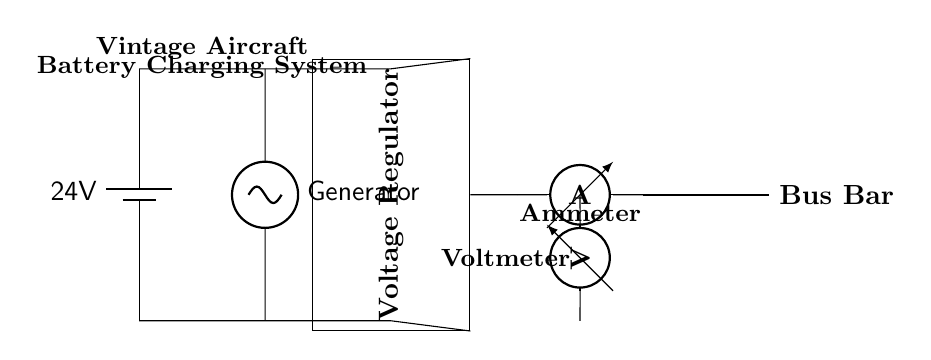What is the voltage rating of the battery? The voltage rating is indicated by the battery symbol in the diagram, labeled as '24V'.
Answer: 24V What component regulates the voltage? The voltage regulator is identified in the diagram as a rectangular block labeled 'Voltage Regulator', and it's responsible for maintaining the output voltage.
Answer: Voltage Regulator How many ammeters are shown in the diagram? There is one ammeter present, as indicated by the single ammeter symbol connected to the circuit.
Answer: One What is the function of the bus bar in this circuit? The bus bar functions as a distribution point for the electrical current to various components, which is evident by its connection from the ammeter to the output side of the circuit.
Answer: Distribution point What is the source of energy in this circuit? The generator is visibly marked in the diagram and is the primary source of electrical energy in conjunction with the battery.
Answer: Generator If the battery is fully charged, what is the expected current flow through the ammeter? The ammeter measures the current flow, which should ideally be positive when the battery is being charged, but the actual value depends on factors like the load and regulator settings.
Answer: Positive Which component helps in measuring electrical pressure in the circuit? The voltmeter, marked in the diagram, is the component designed to measure electrical pressure, or voltage, across specified points in the circuit.
Answer: Voltmeter 